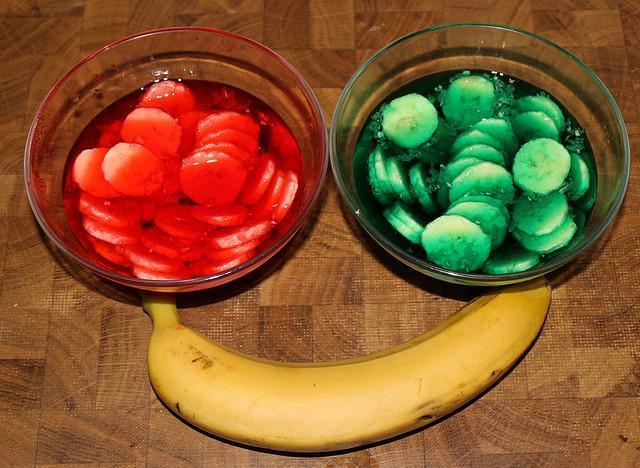How many bananas can be seen?
Give a very brief answer. 3. How many people and standing to the child's left?
Give a very brief answer. 0. 